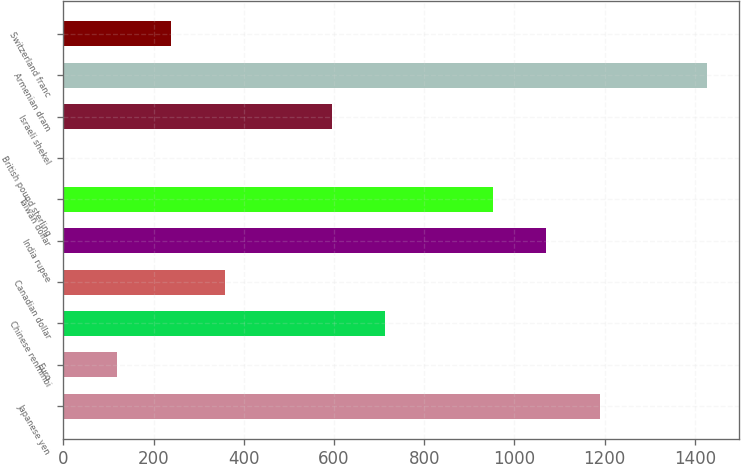Convert chart to OTSL. <chart><loc_0><loc_0><loc_500><loc_500><bar_chart><fcel>Japanese yen<fcel>Euro<fcel>Chinese renminbi<fcel>Canadian dollar<fcel>India rupee<fcel>Taiwan dollar<fcel>British pound sterling<fcel>Israeli shekel<fcel>Armenian dram<fcel>Switzerland franc<nl><fcel>1189.83<fcel>119.55<fcel>714.15<fcel>357.39<fcel>1070.91<fcel>951.99<fcel>0.63<fcel>595.23<fcel>1427.67<fcel>238.47<nl></chart> 